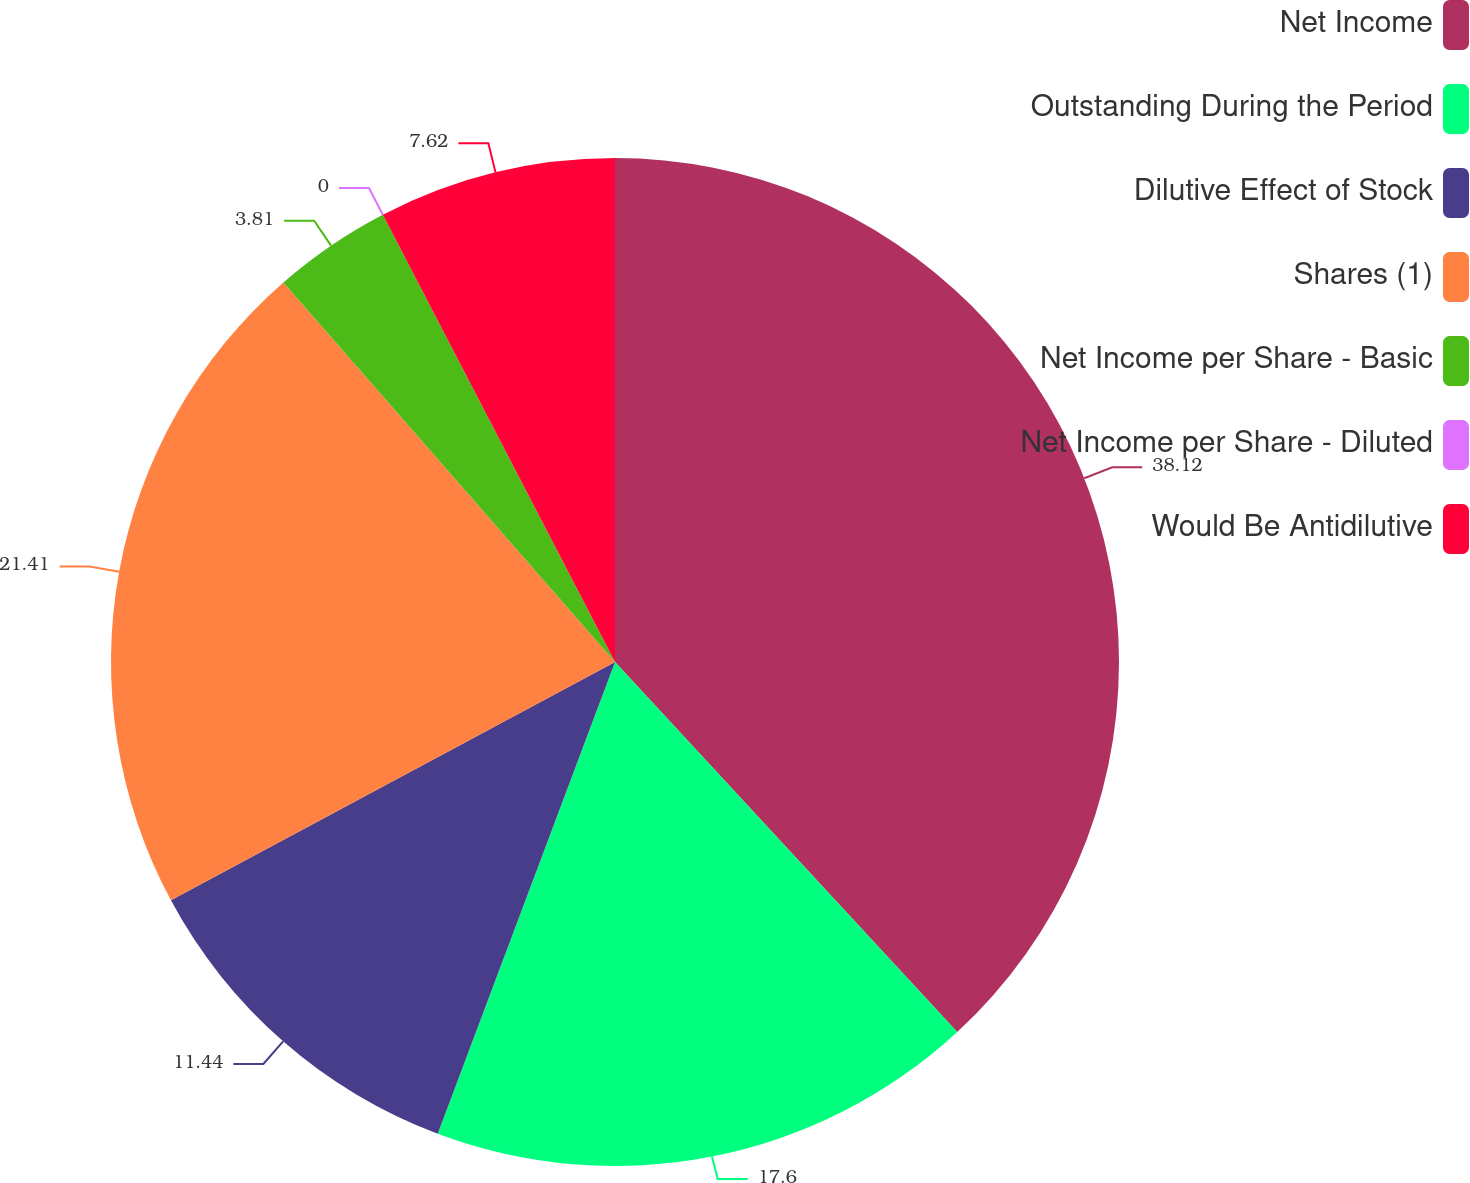Convert chart. <chart><loc_0><loc_0><loc_500><loc_500><pie_chart><fcel>Net Income<fcel>Outstanding During the Period<fcel>Dilutive Effect of Stock<fcel>Shares (1)<fcel>Net Income per Share - Basic<fcel>Net Income per Share - Diluted<fcel>Would Be Antidilutive<nl><fcel>38.12%<fcel>17.6%<fcel>11.44%<fcel>21.41%<fcel>3.81%<fcel>0.0%<fcel>7.62%<nl></chart> 